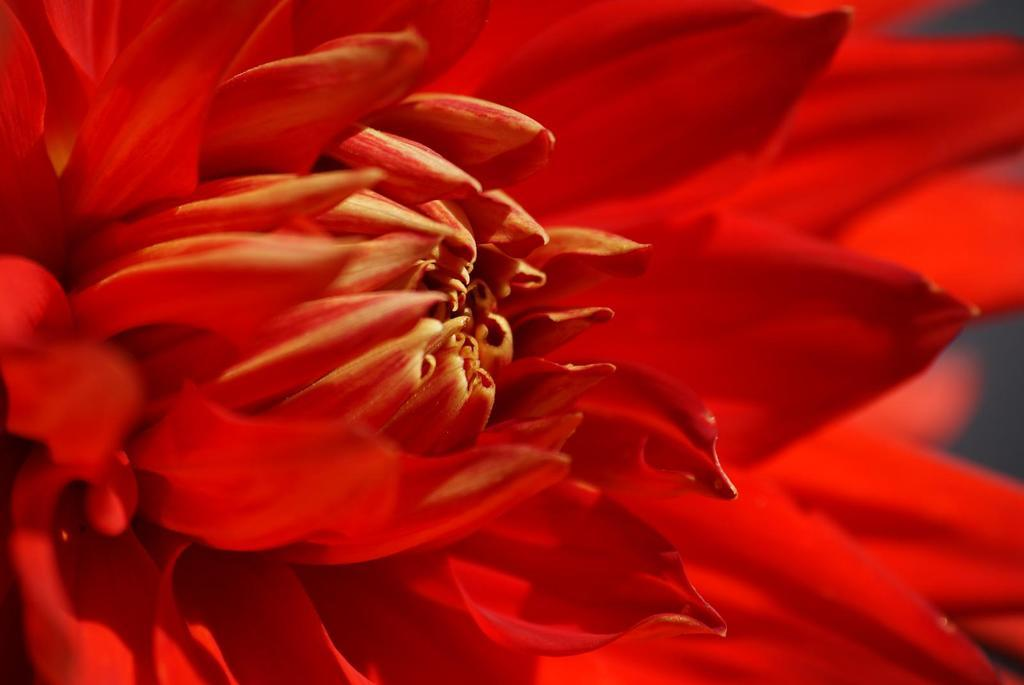What type of flower is present in the image? There is a red color flower in the image. Can you describe the background of the image? The background of the image is blurred. How many sisters are visible in the image? There are no sisters present in the image. What type of fruit is hanging from the flower in the image? There is no fruit, such as a cherry, hanging from the flower in the image. Is there a boot visible in the image? There is no boot present in the image. 